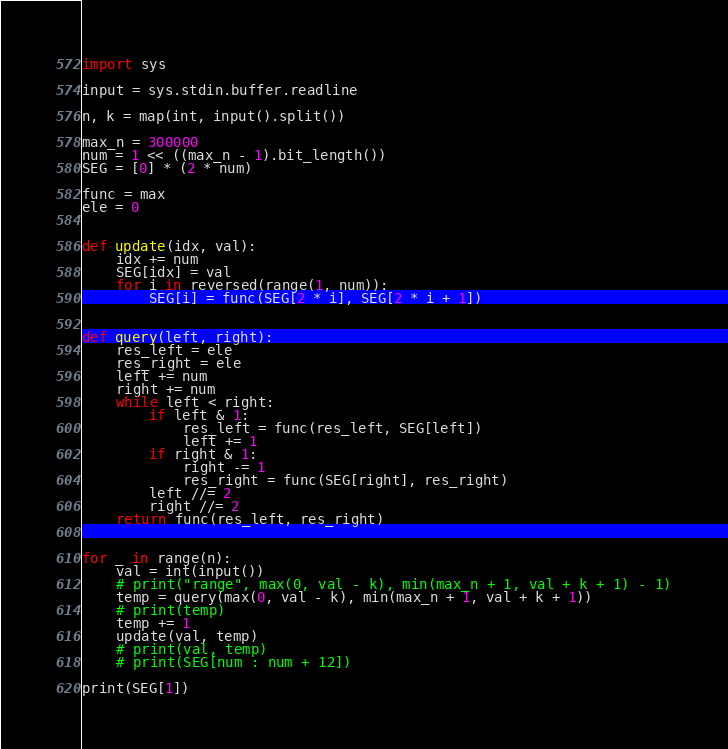Convert code to text. <code><loc_0><loc_0><loc_500><loc_500><_Python_>import sys

input = sys.stdin.buffer.readline

n, k = map(int, input().split())

max_n = 300000
num = 1 << ((max_n - 1).bit_length())
SEG = [0] * (2 * num)

func = max
ele = 0


def update(idx, val):
    idx += num
    SEG[idx] = val
    for i in reversed(range(1, num)):
        SEG[i] = func(SEG[2 * i], SEG[2 * i + 1])


def query(left, right):
    res_left = ele
    res_right = ele
    left += num
    right += num
    while left < right:
        if left & 1:
            res_left = func(res_left, SEG[left])
            left += 1
        if right & 1:
            right -= 1
            res_right = func(SEG[right], res_right)
        left //= 2
        right //= 2
    return func(res_left, res_right)


for _ in range(n):
    val = int(input())
    # print("range", max(0, val - k), min(max_n + 1, val + k + 1) - 1)
    temp = query(max(0, val - k), min(max_n + 1, val + k + 1))
    # print(temp)
    temp += 1
    update(val, temp)
    # print(val, temp)
    # print(SEG[num : num + 12])

print(SEG[1])

</code> 